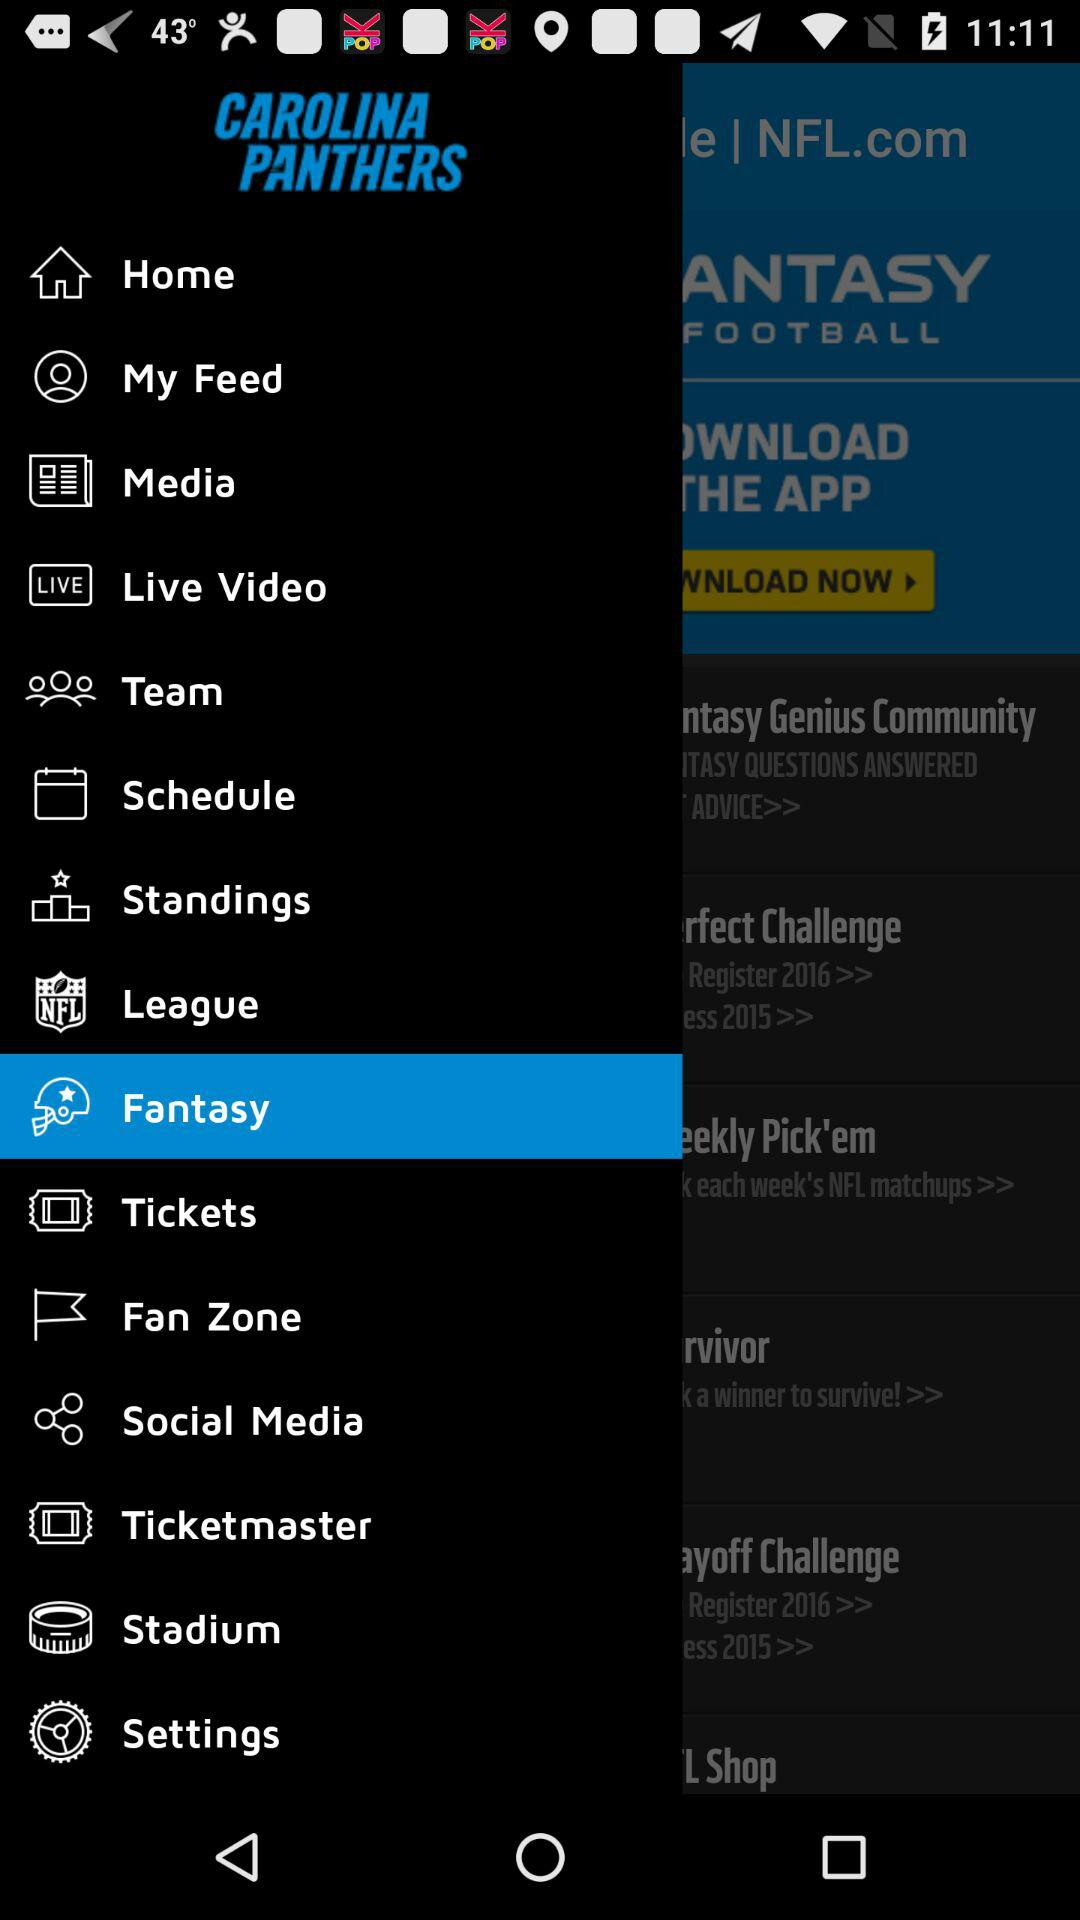What is the application name? The application name is "CAROLINA PANTHERS". 